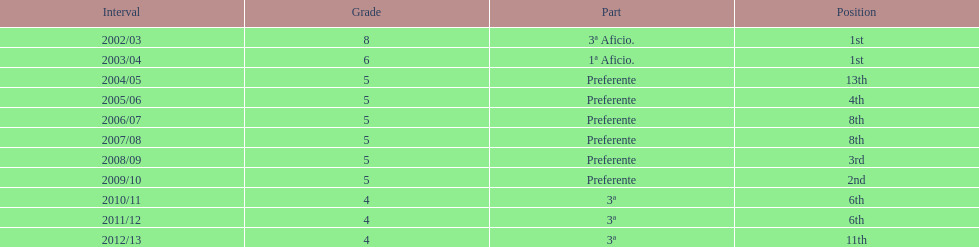In what year did the team achieve the same place as 2010/11? 2011/12. 